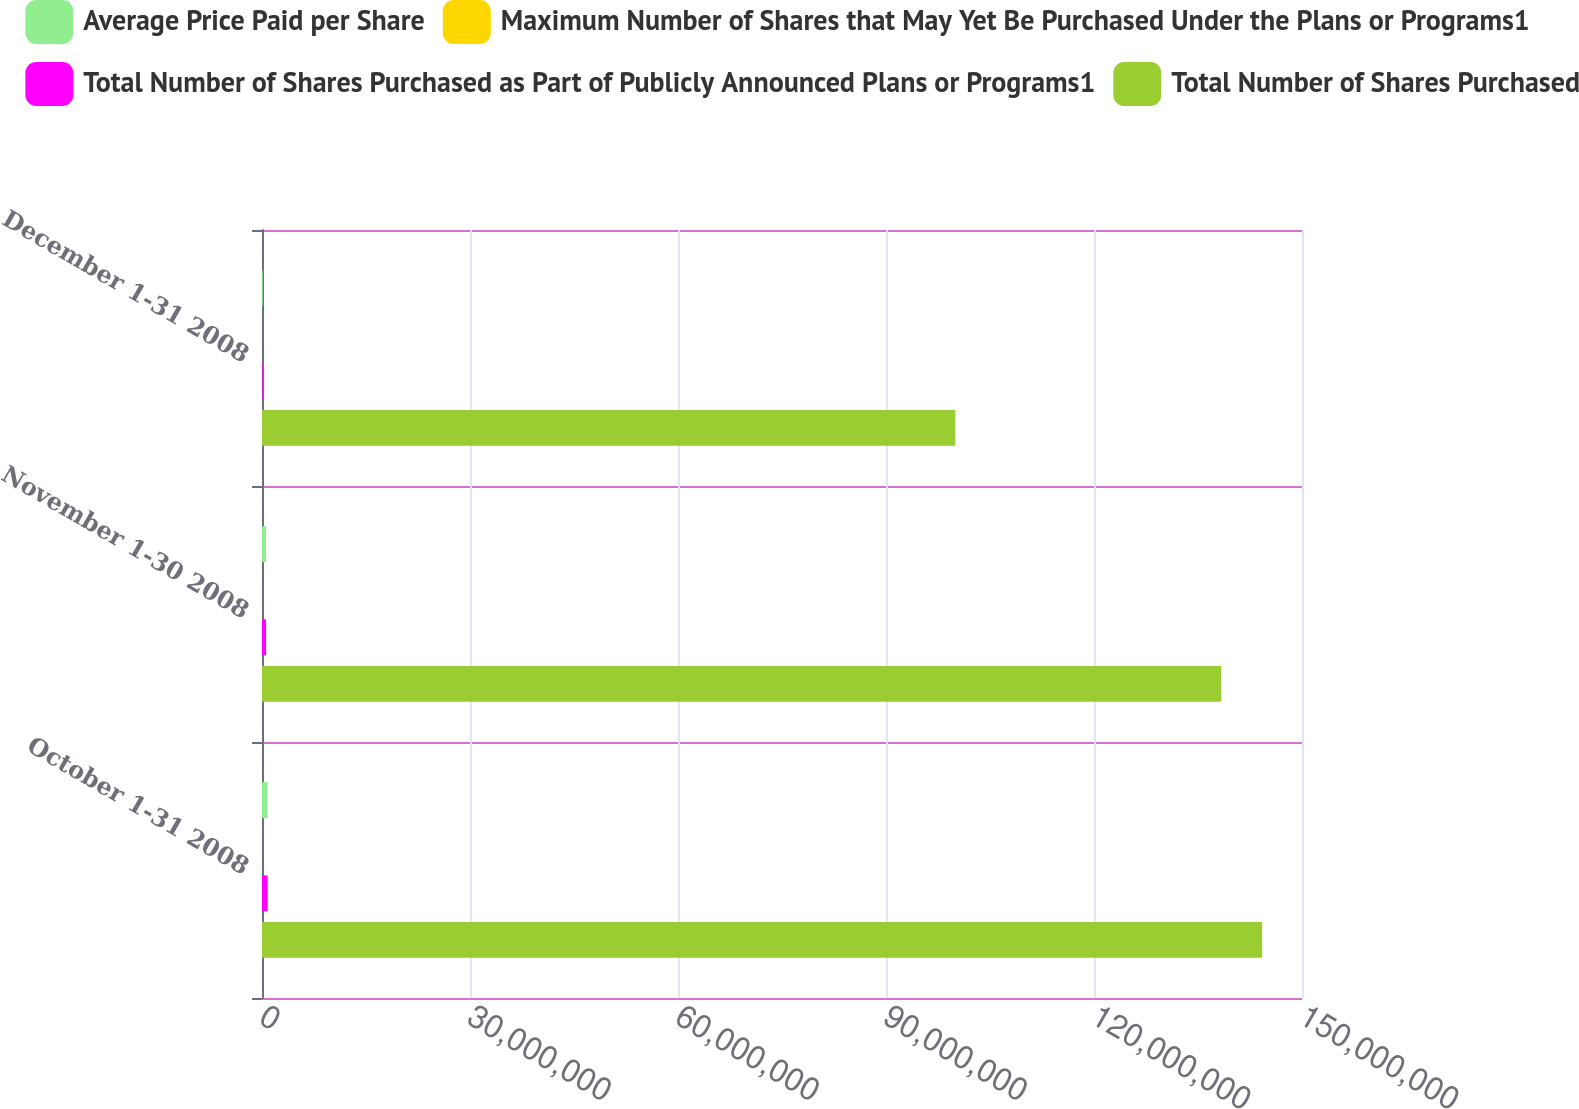<chart> <loc_0><loc_0><loc_500><loc_500><stacked_bar_chart><ecel><fcel>October 1-31 2008<fcel>November 1-30 2008<fcel>December 1-31 2008<nl><fcel>Average Price Paid per Share<fcel>816284<fcel>588721<fcel>100661<nl><fcel>Maximum Number of Shares that May Yet Be Purchased Under the Plans or Programs1<fcel>16.15<fcel>14.88<fcel>14.31<nl><fcel>Total Number of Shares Purchased as Part of Publicly Announced Plans or Programs1<fcel>816284<fcel>588721<fcel>100661<nl><fcel>Total Number of Shares Purchased<fcel>1.44249e+08<fcel>1.38362e+08<fcel>1e+08<nl></chart> 